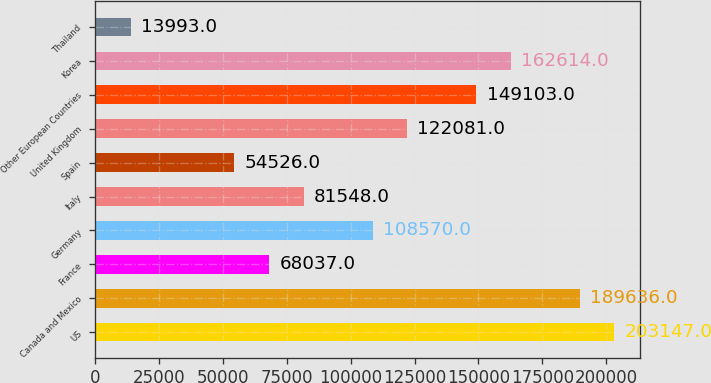Convert chart to OTSL. <chart><loc_0><loc_0><loc_500><loc_500><bar_chart><fcel>US<fcel>Canada and Mexico<fcel>France<fcel>Germany<fcel>Italy<fcel>Spain<fcel>United Kingdom<fcel>Other European Countries<fcel>Korea<fcel>Thailand<nl><fcel>203147<fcel>189636<fcel>68037<fcel>108570<fcel>81548<fcel>54526<fcel>122081<fcel>149103<fcel>162614<fcel>13993<nl></chart> 